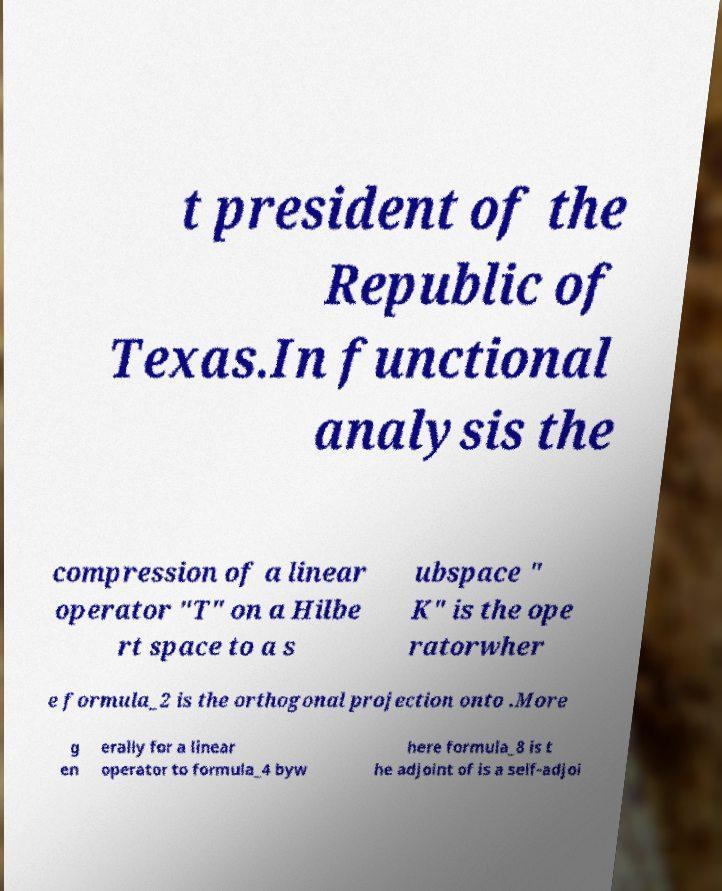There's text embedded in this image that I need extracted. Can you transcribe it verbatim? t president of the Republic of Texas.In functional analysis the compression of a linear operator "T" on a Hilbe rt space to a s ubspace " K" is the ope ratorwher e formula_2 is the orthogonal projection onto .More g en erally for a linear operator to formula_4 byw here formula_8 is t he adjoint of is a self-adjoi 